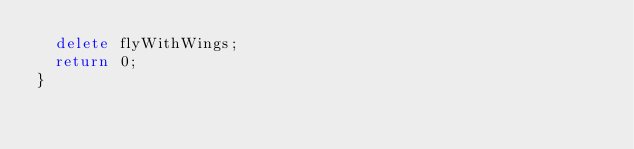Convert code to text. <code><loc_0><loc_0><loc_500><loc_500><_C++_>  delete flyWithWings;
  return 0;
}
</code> 